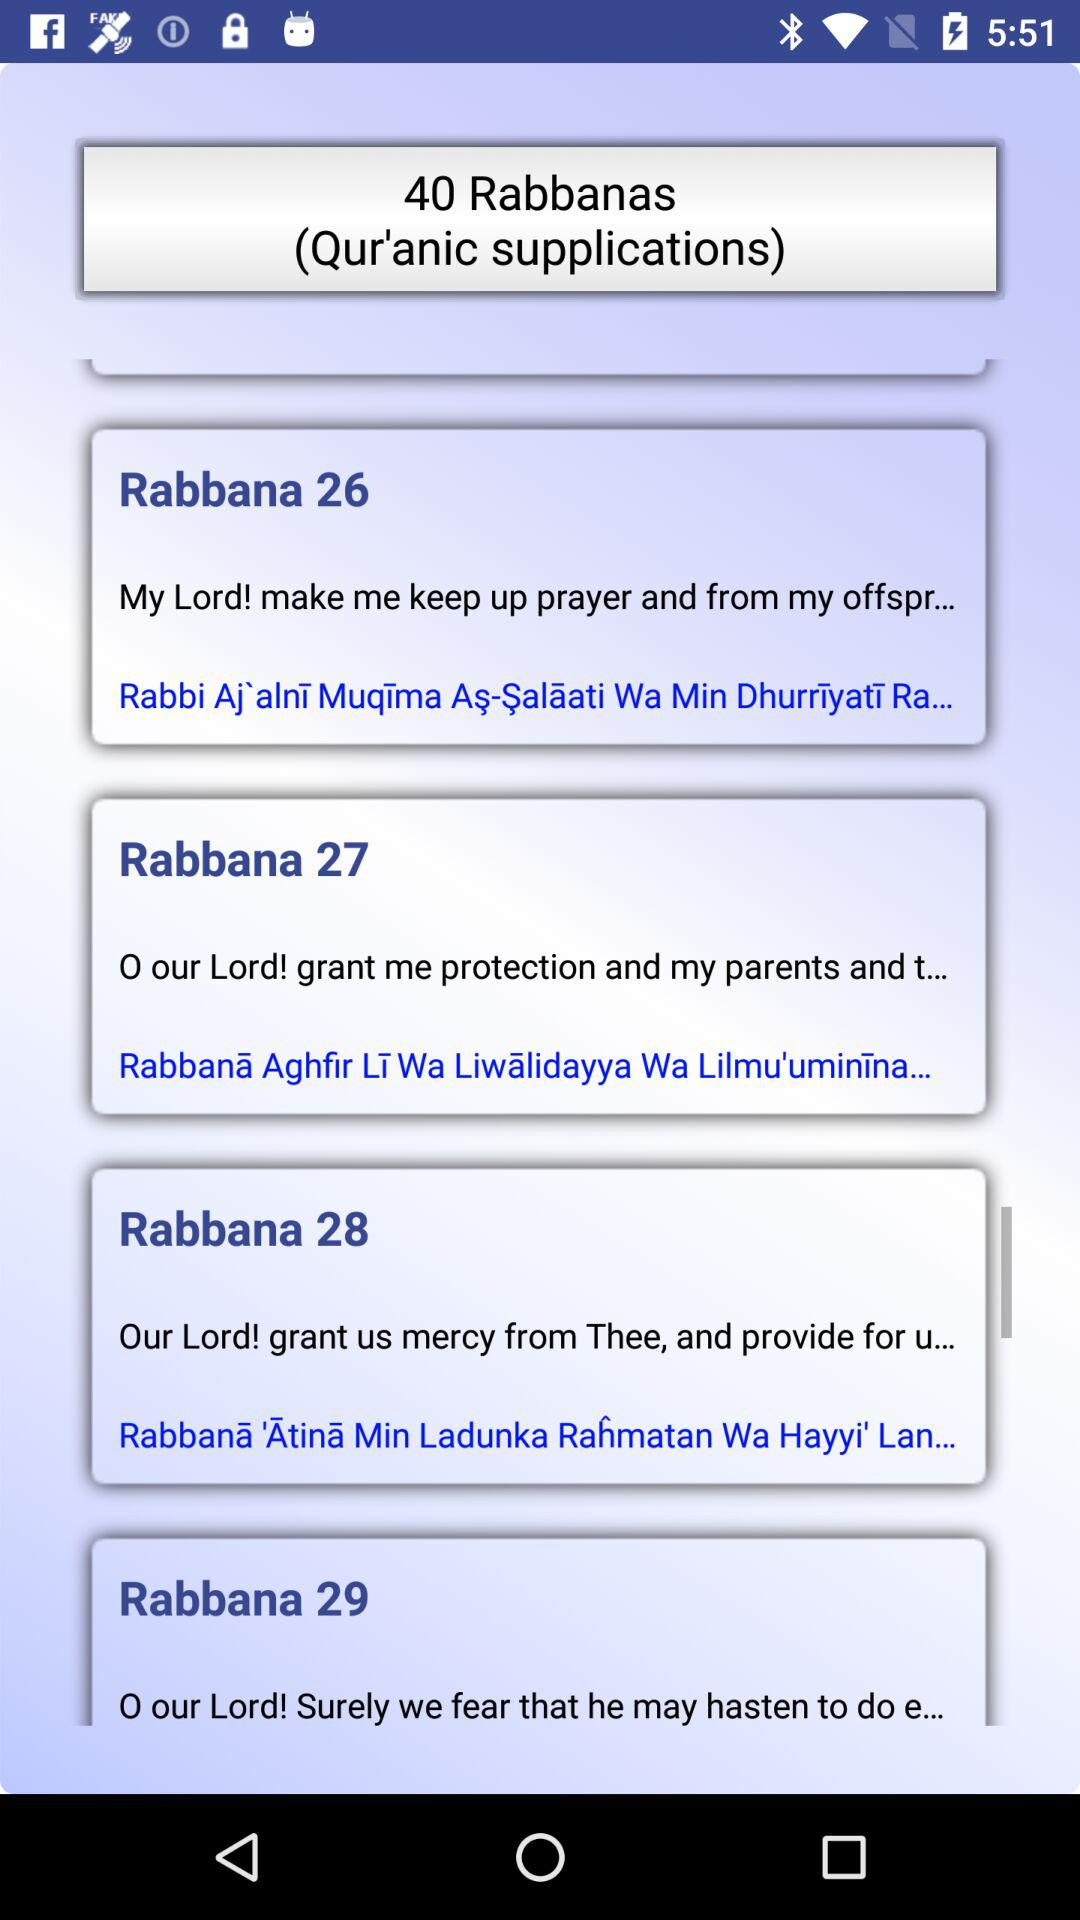How many Rabbana supplications are there in this app?
Answer the question using a single word or phrase. 40 